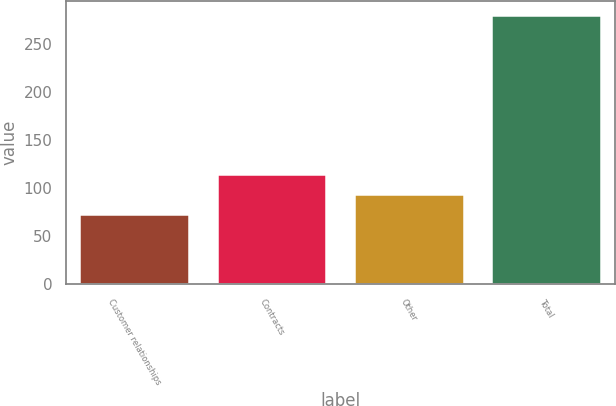Convert chart. <chart><loc_0><loc_0><loc_500><loc_500><bar_chart><fcel>Customer relationships<fcel>Contracts<fcel>Other<fcel>Total<nl><fcel>73<fcel>114.8<fcel>94<fcel>281<nl></chart> 